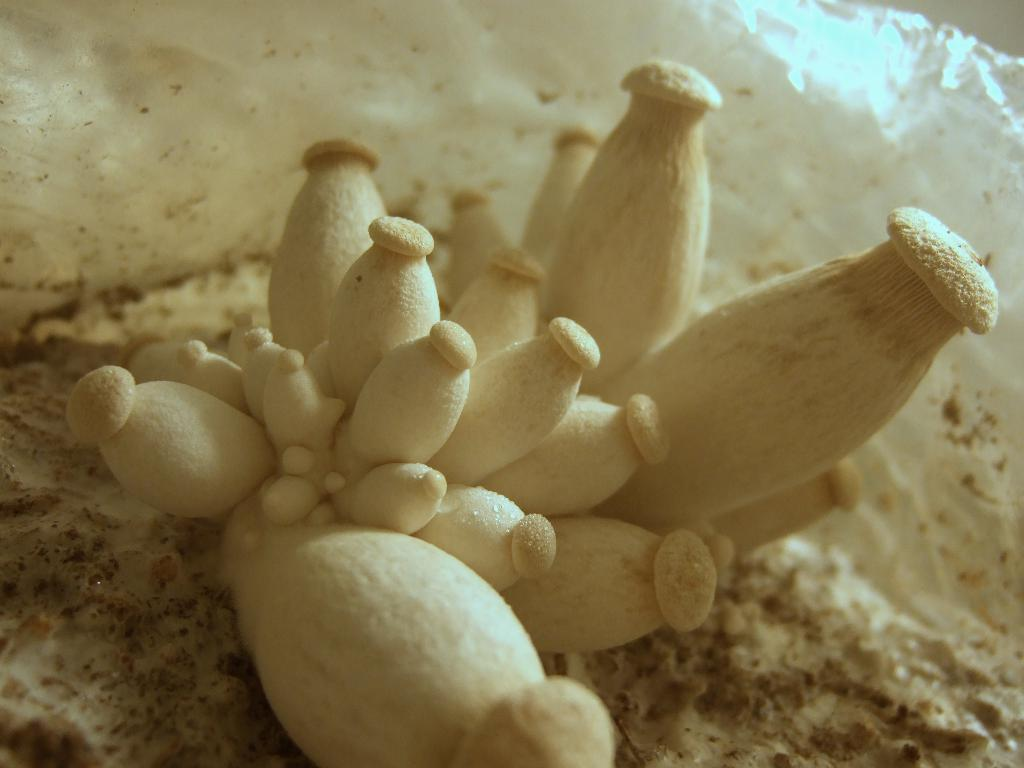What type of vegetation can be seen on the ground in the image? There are mushrooms on the ground in the image. What can be observed about the environment in the background of the image? The background of the image appears to be icy or snowy. Where is the dock located in the image? There is no dock present in the image. What type of print can be seen on the mushrooms in the image? The mushrooms in the image do not have any visible prints. 